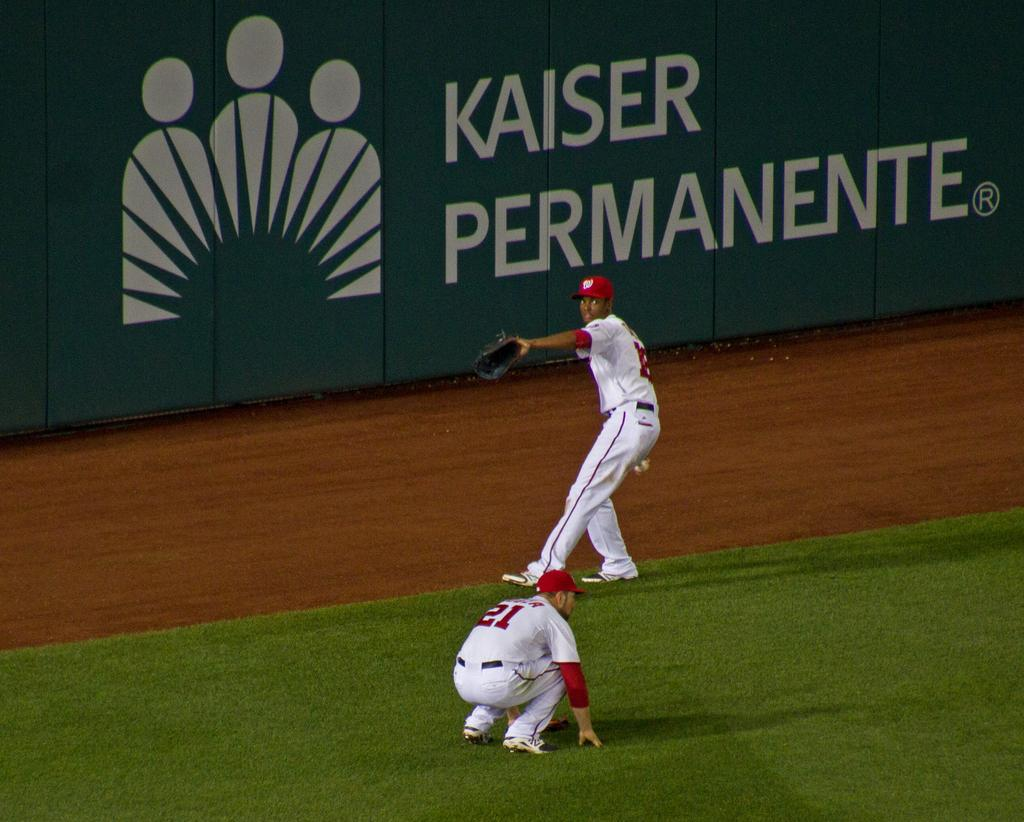<image>
Render a clear and concise summary of the photo. A baseball game is underway and the catcher is throwing the ball by the stadium wall which says Kaiser Permanente. 